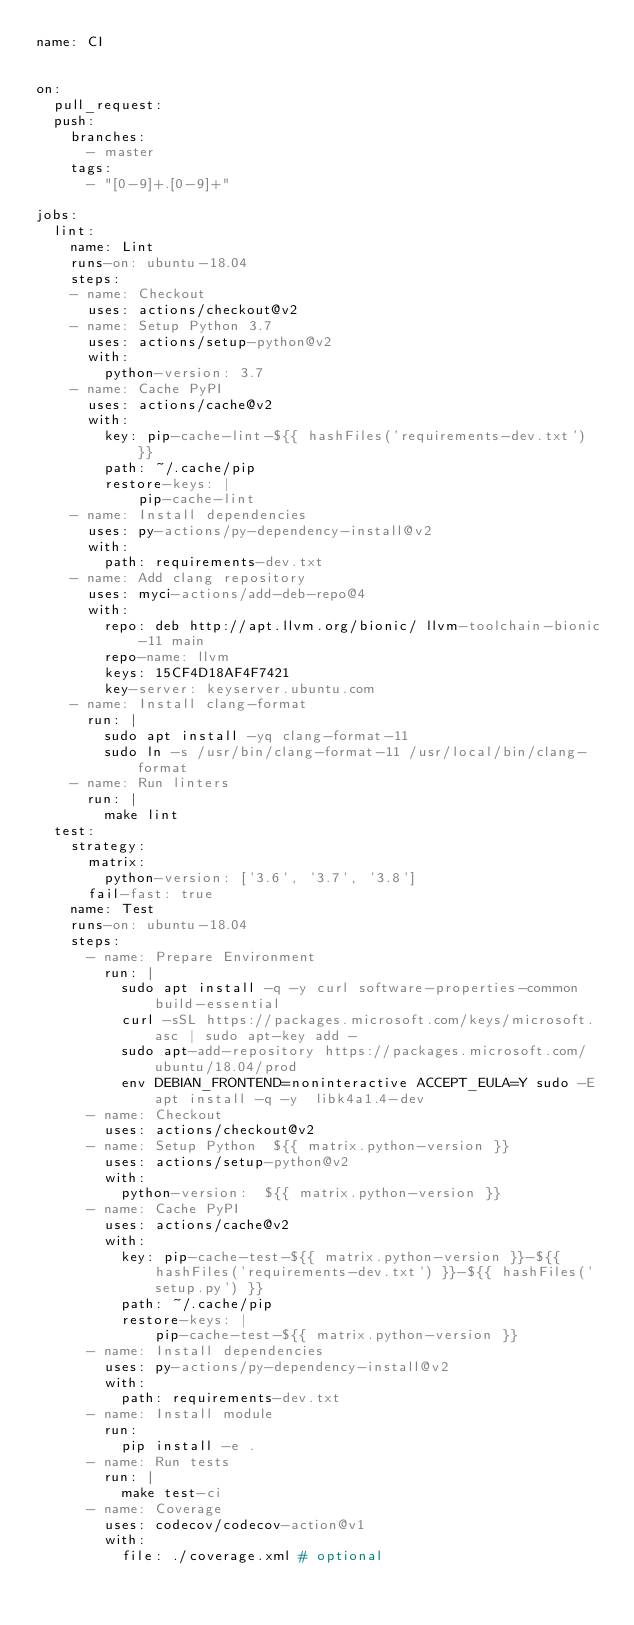Convert code to text. <code><loc_0><loc_0><loc_500><loc_500><_YAML_>name: CI


on:
  pull_request:
  push:
    branches:
      - master
    tags:
      - "[0-9]+.[0-9]+"

jobs:
  lint:
    name: Lint
    runs-on: ubuntu-18.04
    steps:
    - name: Checkout
      uses: actions/checkout@v2
    - name: Setup Python 3.7
      uses: actions/setup-python@v2
      with:
        python-version: 3.7
    - name: Cache PyPI
      uses: actions/cache@v2
      with:
        key: pip-cache-lint-${{ hashFiles('requirements-dev.txt') }}
        path: ~/.cache/pip
        restore-keys: |
            pip-cache-lint
    - name: Install dependencies
      uses: py-actions/py-dependency-install@v2
      with:
        path: requirements-dev.txt
    - name: Add clang repository
      uses: myci-actions/add-deb-repo@4
      with:
        repo: deb http://apt.llvm.org/bionic/ llvm-toolchain-bionic-11 main
        repo-name: llvm
        keys: 15CF4D18AF4F7421
        key-server: keyserver.ubuntu.com
    - name: Install clang-format
      run: |
        sudo apt install -yq clang-format-11
        sudo ln -s /usr/bin/clang-format-11 /usr/local/bin/clang-format
    - name: Run linters
      run: |
        make lint
  test:
    strategy:
      matrix:
        python-version: ['3.6', '3.7', '3.8']
      fail-fast: true
    name: Test
    runs-on: ubuntu-18.04
    steps:
      - name: Prepare Environment
        run: |
          sudo apt install -q -y curl software-properties-common build-essential
          curl -sSL https://packages.microsoft.com/keys/microsoft.asc | sudo apt-key add -
          sudo apt-add-repository https://packages.microsoft.com/ubuntu/18.04/prod
          env DEBIAN_FRONTEND=noninteractive ACCEPT_EULA=Y sudo -E apt install -q -y  libk4a1.4-dev
      - name: Checkout
        uses: actions/checkout@v2
      - name: Setup Python  ${{ matrix.python-version }}
        uses: actions/setup-python@v2
        with:
          python-version:  ${{ matrix.python-version }}
      - name: Cache PyPI
        uses: actions/cache@v2
        with:
          key: pip-cache-test-${{ matrix.python-version }}-${{ hashFiles('requirements-dev.txt') }}-${{ hashFiles('setup.py') }}
          path: ~/.cache/pip
          restore-keys: |
              pip-cache-test-${{ matrix.python-version }}
      - name: Install dependencies
        uses: py-actions/py-dependency-install@v2
        with:
          path: requirements-dev.txt
      - name: Install module
        run:
          pip install -e .
      - name: Run tests
        run: |
          make test-ci
      - name: Coverage
        uses: codecov/codecov-action@v1
        with:
          file: ./coverage.xml # optional
</code> 